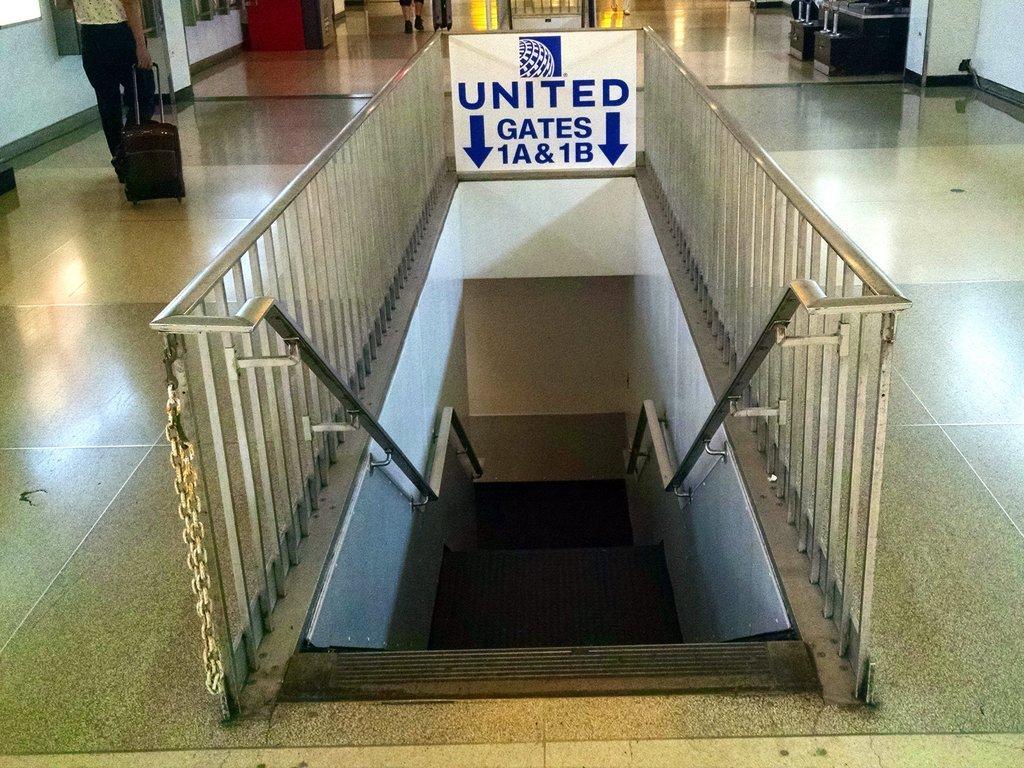In one or two sentences, can you explain what this image depicts? In this image, I can see the stairs with the staircase holders and a board attached to the iron grilles. At the top left side of the image, there is a person standing and holding a trolley bag. At the top right side of the image, I can see an object on the floor. 